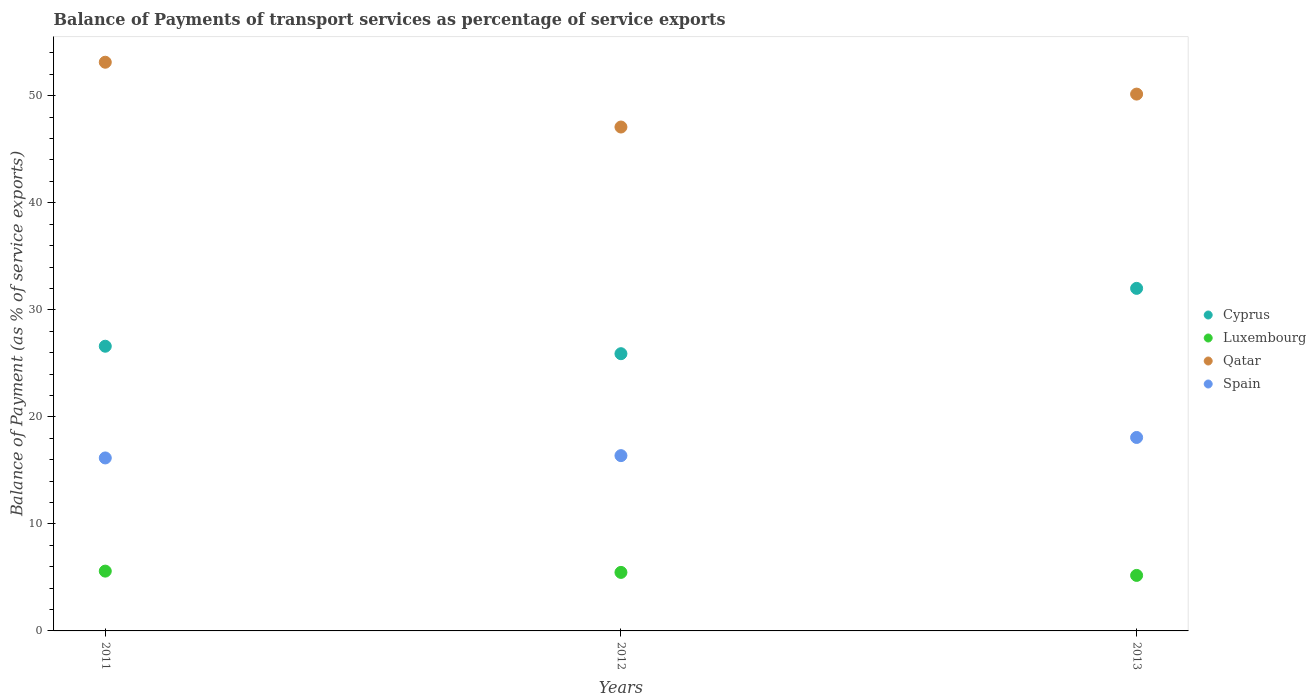How many different coloured dotlines are there?
Provide a short and direct response. 4. Is the number of dotlines equal to the number of legend labels?
Keep it short and to the point. Yes. What is the balance of payments of transport services in Luxembourg in 2013?
Your answer should be very brief. 5.19. Across all years, what is the maximum balance of payments of transport services in Spain?
Make the answer very short. 18.08. Across all years, what is the minimum balance of payments of transport services in Qatar?
Offer a very short reply. 47.08. In which year was the balance of payments of transport services in Luxembourg maximum?
Your response must be concise. 2011. What is the total balance of payments of transport services in Luxembourg in the graph?
Ensure brevity in your answer.  16.24. What is the difference between the balance of payments of transport services in Cyprus in 2011 and that in 2012?
Keep it short and to the point. 0.7. What is the difference between the balance of payments of transport services in Qatar in 2011 and the balance of payments of transport services in Spain in 2012?
Provide a short and direct response. 36.76. What is the average balance of payments of transport services in Spain per year?
Your answer should be very brief. 16.87. In the year 2013, what is the difference between the balance of payments of transport services in Qatar and balance of payments of transport services in Luxembourg?
Offer a very short reply. 44.97. In how many years, is the balance of payments of transport services in Luxembourg greater than 42 %?
Your answer should be very brief. 0. What is the ratio of the balance of payments of transport services in Luxembourg in 2011 to that in 2012?
Give a very brief answer. 1.02. Is the balance of payments of transport services in Qatar in 2011 less than that in 2013?
Offer a very short reply. No. What is the difference between the highest and the second highest balance of payments of transport services in Qatar?
Your answer should be compact. 2.98. What is the difference between the highest and the lowest balance of payments of transport services in Qatar?
Provide a succinct answer. 6.05. In how many years, is the balance of payments of transport services in Luxembourg greater than the average balance of payments of transport services in Luxembourg taken over all years?
Ensure brevity in your answer.  2. Is it the case that in every year, the sum of the balance of payments of transport services in Spain and balance of payments of transport services in Luxembourg  is greater than the balance of payments of transport services in Qatar?
Provide a short and direct response. No. Is the balance of payments of transport services in Cyprus strictly greater than the balance of payments of transport services in Qatar over the years?
Provide a succinct answer. No. How many dotlines are there?
Give a very brief answer. 4. Are the values on the major ticks of Y-axis written in scientific E-notation?
Ensure brevity in your answer.  No. Does the graph contain any zero values?
Provide a succinct answer. No. Does the graph contain grids?
Ensure brevity in your answer.  No. Where does the legend appear in the graph?
Ensure brevity in your answer.  Center right. How many legend labels are there?
Ensure brevity in your answer.  4. How are the legend labels stacked?
Offer a very short reply. Vertical. What is the title of the graph?
Offer a very short reply. Balance of Payments of transport services as percentage of service exports. Does "St. Vincent and the Grenadines" appear as one of the legend labels in the graph?
Make the answer very short. No. What is the label or title of the Y-axis?
Provide a succinct answer. Balance of Payment (as % of service exports). What is the Balance of Payment (as % of service exports) of Cyprus in 2011?
Offer a very short reply. 26.6. What is the Balance of Payment (as % of service exports) of Luxembourg in 2011?
Ensure brevity in your answer.  5.59. What is the Balance of Payment (as % of service exports) of Qatar in 2011?
Your answer should be very brief. 53.13. What is the Balance of Payment (as % of service exports) of Spain in 2011?
Provide a short and direct response. 16.16. What is the Balance of Payment (as % of service exports) of Cyprus in 2012?
Ensure brevity in your answer.  25.9. What is the Balance of Payment (as % of service exports) of Luxembourg in 2012?
Provide a short and direct response. 5.47. What is the Balance of Payment (as % of service exports) of Qatar in 2012?
Make the answer very short. 47.08. What is the Balance of Payment (as % of service exports) of Spain in 2012?
Provide a succinct answer. 16.38. What is the Balance of Payment (as % of service exports) of Cyprus in 2013?
Provide a short and direct response. 32.01. What is the Balance of Payment (as % of service exports) of Luxembourg in 2013?
Ensure brevity in your answer.  5.19. What is the Balance of Payment (as % of service exports) in Qatar in 2013?
Your answer should be compact. 50.16. What is the Balance of Payment (as % of service exports) of Spain in 2013?
Ensure brevity in your answer.  18.08. Across all years, what is the maximum Balance of Payment (as % of service exports) of Cyprus?
Provide a succinct answer. 32.01. Across all years, what is the maximum Balance of Payment (as % of service exports) in Luxembourg?
Ensure brevity in your answer.  5.59. Across all years, what is the maximum Balance of Payment (as % of service exports) of Qatar?
Ensure brevity in your answer.  53.13. Across all years, what is the maximum Balance of Payment (as % of service exports) in Spain?
Provide a succinct answer. 18.08. Across all years, what is the minimum Balance of Payment (as % of service exports) in Cyprus?
Your answer should be compact. 25.9. Across all years, what is the minimum Balance of Payment (as % of service exports) of Luxembourg?
Make the answer very short. 5.19. Across all years, what is the minimum Balance of Payment (as % of service exports) in Qatar?
Offer a terse response. 47.08. Across all years, what is the minimum Balance of Payment (as % of service exports) of Spain?
Ensure brevity in your answer.  16.16. What is the total Balance of Payment (as % of service exports) of Cyprus in the graph?
Provide a succinct answer. 84.51. What is the total Balance of Payment (as % of service exports) in Luxembourg in the graph?
Your answer should be very brief. 16.24. What is the total Balance of Payment (as % of service exports) of Qatar in the graph?
Provide a succinct answer. 150.37. What is the total Balance of Payment (as % of service exports) of Spain in the graph?
Offer a terse response. 50.62. What is the difference between the Balance of Payment (as % of service exports) in Cyprus in 2011 and that in 2012?
Offer a very short reply. 0.7. What is the difference between the Balance of Payment (as % of service exports) in Luxembourg in 2011 and that in 2012?
Offer a terse response. 0.12. What is the difference between the Balance of Payment (as % of service exports) of Qatar in 2011 and that in 2012?
Provide a short and direct response. 6.05. What is the difference between the Balance of Payment (as % of service exports) in Spain in 2011 and that in 2012?
Ensure brevity in your answer.  -0.22. What is the difference between the Balance of Payment (as % of service exports) of Cyprus in 2011 and that in 2013?
Your answer should be compact. -5.41. What is the difference between the Balance of Payment (as % of service exports) of Luxembourg in 2011 and that in 2013?
Give a very brief answer. 0.4. What is the difference between the Balance of Payment (as % of service exports) of Qatar in 2011 and that in 2013?
Keep it short and to the point. 2.98. What is the difference between the Balance of Payment (as % of service exports) in Spain in 2011 and that in 2013?
Ensure brevity in your answer.  -1.91. What is the difference between the Balance of Payment (as % of service exports) in Cyprus in 2012 and that in 2013?
Ensure brevity in your answer.  -6.1. What is the difference between the Balance of Payment (as % of service exports) in Luxembourg in 2012 and that in 2013?
Give a very brief answer. 0.28. What is the difference between the Balance of Payment (as % of service exports) of Qatar in 2012 and that in 2013?
Provide a succinct answer. -3.08. What is the difference between the Balance of Payment (as % of service exports) in Spain in 2012 and that in 2013?
Give a very brief answer. -1.7. What is the difference between the Balance of Payment (as % of service exports) in Cyprus in 2011 and the Balance of Payment (as % of service exports) in Luxembourg in 2012?
Offer a terse response. 21.13. What is the difference between the Balance of Payment (as % of service exports) in Cyprus in 2011 and the Balance of Payment (as % of service exports) in Qatar in 2012?
Make the answer very short. -20.48. What is the difference between the Balance of Payment (as % of service exports) of Cyprus in 2011 and the Balance of Payment (as % of service exports) of Spain in 2012?
Your answer should be compact. 10.22. What is the difference between the Balance of Payment (as % of service exports) of Luxembourg in 2011 and the Balance of Payment (as % of service exports) of Qatar in 2012?
Provide a short and direct response. -41.49. What is the difference between the Balance of Payment (as % of service exports) in Luxembourg in 2011 and the Balance of Payment (as % of service exports) in Spain in 2012?
Offer a terse response. -10.79. What is the difference between the Balance of Payment (as % of service exports) in Qatar in 2011 and the Balance of Payment (as % of service exports) in Spain in 2012?
Your answer should be compact. 36.76. What is the difference between the Balance of Payment (as % of service exports) of Cyprus in 2011 and the Balance of Payment (as % of service exports) of Luxembourg in 2013?
Your response must be concise. 21.41. What is the difference between the Balance of Payment (as % of service exports) of Cyprus in 2011 and the Balance of Payment (as % of service exports) of Qatar in 2013?
Give a very brief answer. -23.56. What is the difference between the Balance of Payment (as % of service exports) in Cyprus in 2011 and the Balance of Payment (as % of service exports) in Spain in 2013?
Offer a very short reply. 8.52. What is the difference between the Balance of Payment (as % of service exports) of Luxembourg in 2011 and the Balance of Payment (as % of service exports) of Qatar in 2013?
Offer a terse response. -44.57. What is the difference between the Balance of Payment (as % of service exports) in Luxembourg in 2011 and the Balance of Payment (as % of service exports) in Spain in 2013?
Ensure brevity in your answer.  -12.49. What is the difference between the Balance of Payment (as % of service exports) in Qatar in 2011 and the Balance of Payment (as % of service exports) in Spain in 2013?
Your answer should be very brief. 35.06. What is the difference between the Balance of Payment (as % of service exports) in Cyprus in 2012 and the Balance of Payment (as % of service exports) in Luxembourg in 2013?
Provide a short and direct response. 20.71. What is the difference between the Balance of Payment (as % of service exports) in Cyprus in 2012 and the Balance of Payment (as % of service exports) in Qatar in 2013?
Offer a terse response. -24.26. What is the difference between the Balance of Payment (as % of service exports) in Cyprus in 2012 and the Balance of Payment (as % of service exports) in Spain in 2013?
Ensure brevity in your answer.  7.83. What is the difference between the Balance of Payment (as % of service exports) in Luxembourg in 2012 and the Balance of Payment (as % of service exports) in Qatar in 2013?
Your answer should be very brief. -44.69. What is the difference between the Balance of Payment (as % of service exports) in Luxembourg in 2012 and the Balance of Payment (as % of service exports) in Spain in 2013?
Your answer should be very brief. -12.61. What is the difference between the Balance of Payment (as % of service exports) in Qatar in 2012 and the Balance of Payment (as % of service exports) in Spain in 2013?
Your response must be concise. 29.01. What is the average Balance of Payment (as % of service exports) in Cyprus per year?
Your answer should be very brief. 28.17. What is the average Balance of Payment (as % of service exports) in Luxembourg per year?
Offer a very short reply. 5.41. What is the average Balance of Payment (as % of service exports) of Qatar per year?
Give a very brief answer. 50.12. What is the average Balance of Payment (as % of service exports) of Spain per year?
Offer a very short reply. 16.87. In the year 2011, what is the difference between the Balance of Payment (as % of service exports) in Cyprus and Balance of Payment (as % of service exports) in Luxembourg?
Make the answer very short. 21.01. In the year 2011, what is the difference between the Balance of Payment (as % of service exports) of Cyprus and Balance of Payment (as % of service exports) of Qatar?
Provide a succinct answer. -26.53. In the year 2011, what is the difference between the Balance of Payment (as % of service exports) in Cyprus and Balance of Payment (as % of service exports) in Spain?
Make the answer very short. 10.44. In the year 2011, what is the difference between the Balance of Payment (as % of service exports) of Luxembourg and Balance of Payment (as % of service exports) of Qatar?
Your response must be concise. -47.55. In the year 2011, what is the difference between the Balance of Payment (as % of service exports) in Luxembourg and Balance of Payment (as % of service exports) in Spain?
Your answer should be compact. -10.57. In the year 2011, what is the difference between the Balance of Payment (as % of service exports) of Qatar and Balance of Payment (as % of service exports) of Spain?
Give a very brief answer. 36.97. In the year 2012, what is the difference between the Balance of Payment (as % of service exports) in Cyprus and Balance of Payment (as % of service exports) in Luxembourg?
Give a very brief answer. 20.43. In the year 2012, what is the difference between the Balance of Payment (as % of service exports) in Cyprus and Balance of Payment (as % of service exports) in Qatar?
Your answer should be very brief. -21.18. In the year 2012, what is the difference between the Balance of Payment (as % of service exports) in Cyprus and Balance of Payment (as % of service exports) in Spain?
Offer a very short reply. 9.52. In the year 2012, what is the difference between the Balance of Payment (as % of service exports) of Luxembourg and Balance of Payment (as % of service exports) of Qatar?
Your answer should be very brief. -41.61. In the year 2012, what is the difference between the Balance of Payment (as % of service exports) of Luxembourg and Balance of Payment (as % of service exports) of Spain?
Your response must be concise. -10.91. In the year 2012, what is the difference between the Balance of Payment (as % of service exports) in Qatar and Balance of Payment (as % of service exports) in Spain?
Your answer should be very brief. 30.7. In the year 2013, what is the difference between the Balance of Payment (as % of service exports) in Cyprus and Balance of Payment (as % of service exports) in Luxembourg?
Offer a very short reply. 26.82. In the year 2013, what is the difference between the Balance of Payment (as % of service exports) of Cyprus and Balance of Payment (as % of service exports) of Qatar?
Ensure brevity in your answer.  -18.15. In the year 2013, what is the difference between the Balance of Payment (as % of service exports) in Cyprus and Balance of Payment (as % of service exports) in Spain?
Your answer should be compact. 13.93. In the year 2013, what is the difference between the Balance of Payment (as % of service exports) of Luxembourg and Balance of Payment (as % of service exports) of Qatar?
Keep it short and to the point. -44.97. In the year 2013, what is the difference between the Balance of Payment (as % of service exports) in Luxembourg and Balance of Payment (as % of service exports) in Spain?
Provide a short and direct response. -12.89. In the year 2013, what is the difference between the Balance of Payment (as % of service exports) in Qatar and Balance of Payment (as % of service exports) in Spain?
Your answer should be very brief. 32.08. What is the ratio of the Balance of Payment (as % of service exports) of Cyprus in 2011 to that in 2012?
Your answer should be very brief. 1.03. What is the ratio of the Balance of Payment (as % of service exports) in Luxembourg in 2011 to that in 2012?
Your answer should be very brief. 1.02. What is the ratio of the Balance of Payment (as % of service exports) of Qatar in 2011 to that in 2012?
Keep it short and to the point. 1.13. What is the ratio of the Balance of Payment (as % of service exports) of Spain in 2011 to that in 2012?
Keep it short and to the point. 0.99. What is the ratio of the Balance of Payment (as % of service exports) in Cyprus in 2011 to that in 2013?
Keep it short and to the point. 0.83. What is the ratio of the Balance of Payment (as % of service exports) in Luxembourg in 2011 to that in 2013?
Offer a terse response. 1.08. What is the ratio of the Balance of Payment (as % of service exports) of Qatar in 2011 to that in 2013?
Your response must be concise. 1.06. What is the ratio of the Balance of Payment (as % of service exports) in Spain in 2011 to that in 2013?
Provide a succinct answer. 0.89. What is the ratio of the Balance of Payment (as % of service exports) of Cyprus in 2012 to that in 2013?
Offer a very short reply. 0.81. What is the ratio of the Balance of Payment (as % of service exports) of Luxembourg in 2012 to that in 2013?
Offer a terse response. 1.05. What is the ratio of the Balance of Payment (as % of service exports) in Qatar in 2012 to that in 2013?
Make the answer very short. 0.94. What is the ratio of the Balance of Payment (as % of service exports) in Spain in 2012 to that in 2013?
Ensure brevity in your answer.  0.91. What is the difference between the highest and the second highest Balance of Payment (as % of service exports) of Cyprus?
Your response must be concise. 5.41. What is the difference between the highest and the second highest Balance of Payment (as % of service exports) of Luxembourg?
Provide a short and direct response. 0.12. What is the difference between the highest and the second highest Balance of Payment (as % of service exports) in Qatar?
Give a very brief answer. 2.98. What is the difference between the highest and the second highest Balance of Payment (as % of service exports) of Spain?
Your answer should be very brief. 1.7. What is the difference between the highest and the lowest Balance of Payment (as % of service exports) in Cyprus?
Make the answer very short. 6.1. What is the difference between the highest and the lowest Balance of Payment (as % of service exports) in Luxembourg?
Keep it short and to the point. 0.4. What is the difference between the highest and the lowest Balance of Payment (as % of service exports) in Qatar?
Your answer should be compact. 6.05. What is the difference between the highest and the lowest Balance of Payment (as % of service exports) of Spain?
Provide a succinct answer. 1.91. 